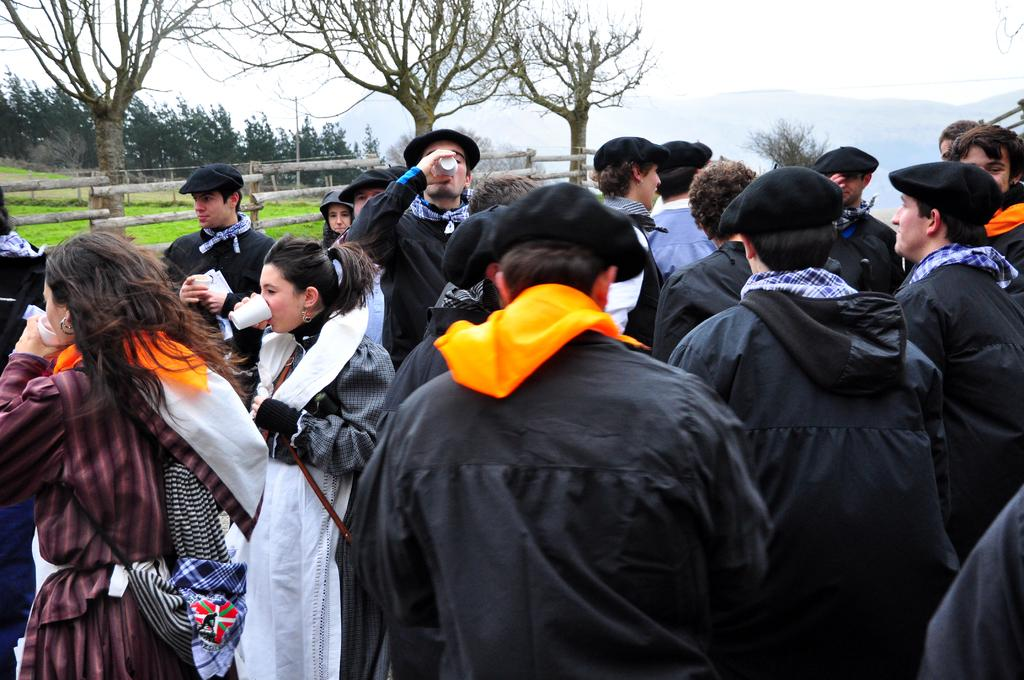What is the main subject of the image? There are persons in the center of the image. What can be seen in the background of the image? There are trees in the background of the image. What type of vegetation is visible in the image? There is grass visible in the image. What type of fencing is present in the image? There is a wooden fencing in the image. How many trucks are parked near the wooden fencing in the image? There are no trucks present in the image. What action are the persons in the image performing? The provided facts do not specify any actions being performed by the persons in the image. 